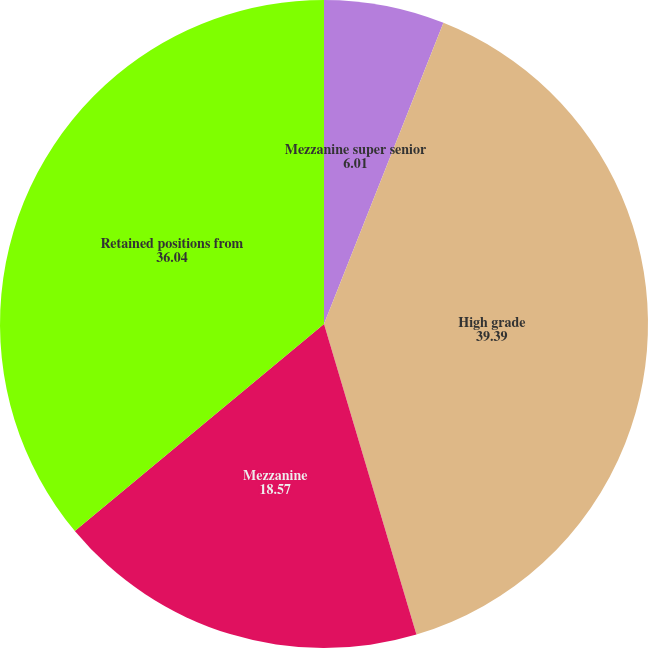<chart> <loc_0><loc_0><loc_500><loc_500><pie_chart><fcel>Mezzanine super senior<fcel>High grade<fcel>Mezzanine<fcel>Retained positions from<nl><fcel>6.01%<fcel>39.39%<fcel>18.57%<fcel>36.04%<nl></chart> 